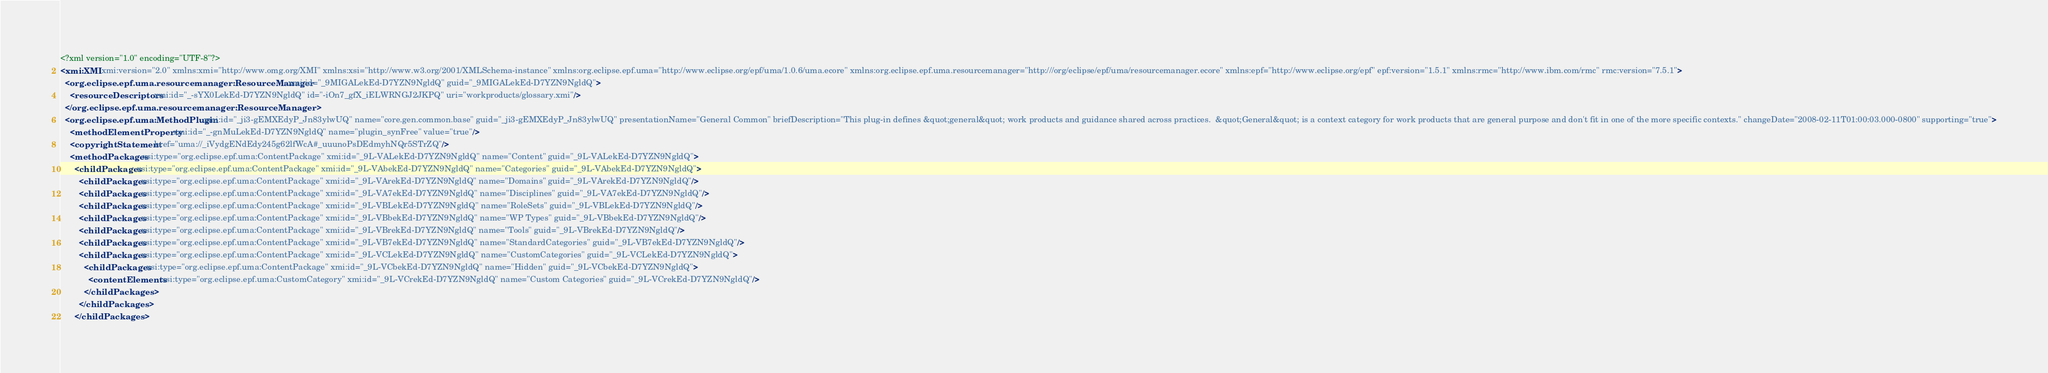<code> <loc_0><loc_0><loc_500><loc_500><_XML_><?xml version="1.0" encoding="UTF-8"?>
<xmi:XMI xmi:version="2.0" xmlns:xmi="http://www.omg.org/XMI" xmlns:xsi="http://www.w3.org/2001/XMLSchema-instance" xmlns:org.eclipse.epf.uma="http://www.eclipse.org/epf/uma/1.0.6/uma.ecore" xmlns:org.eclipse.epf.uma.resourcemanager="http:///org/eclipse/epf/uma/resourcemanager.ecore" xmlns:epf="http://www.eclipse.org/epf" epf:version="1.5.1" xmlns:rmc="http://www.ibm.com/rmc" rmc:version="7.5.1">
  <org.eclipse.epf.uma.resourcemanager:ResourceManager xmi:id="_9MIGALekEd-D7YZN9NgldQ" guid="_9MIGALekEd-D7YZN9NgldQ">
    <resourceDescriptors xmi:id="_-sYX0LekEd-D7YZN9NgldQ" id="-iOn7_gfX_iELWRNGJ2JKPQ" uri="workproducts/glossary.xmi"/>
  </org.eclipse.epf.uma.resourcemanager:ResourceManager>
  <org.eclipse.epf.uma:MethodPlugin xmi:id="_ji3-gEMXEdyP_Jn83ylwUQ" name="core.gen.common.base" guid="_ji3-gEMXEdyP_Jn83ylwUQ" presentationName="General Common" briefDescription="This plug-in defines &quot;general&quot; work products and guidance shared across practices.  &quot;General&quot; is a context category for work products that are general purpose and don't fit in one of the more specific contexts." changeDate="2008-02-11T01:00:03.000-0800" supporting="true">
    <methodElementProperty xmi:id="_-gnMuLekEd-D7YZN9NgldQ" name="plugin_synFree" value="true"/>
    <copyrightStatement href="uma://_iVydgENdEdy245g62lfWcA#_uuunoPsDEdmyhNQr5STrZQ"/>
    <methodPackages xsi:type="org.eclipse.epf.uma:ContentPackage" xmi:id="_9L-VALekEd-D7YZN9NgldQ" name="Content" guid="_9L-VALekEd-D7YZN9NgldQ">
      <childPackages xsi:type="org.eclipse.epf.uma:ContentPackage" xmi:id="_9L-VAbekEd-D7YZN9NgldQ" name="Categories" guid="_9L-VAbekEd-D7YZN9NgldQ">
        <childPackages xsi:type="org.eclipse.epf.uma:ContentPackage" xmi:id="_9L-VArekEd-D7YZN9NgldQ" name="Domains" guid="_9L-VArekEd-D7YZN9NgldQ"/>
        <childPackages xsi:type="org.eclipse.epf.uma:ContentPackage" xmi:id="_9L-VA7ekEd-D7YZN9NgldQ" name="Disciplines" guid="_9L-VA7ekEd-D7YZN9NgldQ"/>
        <childPackages xsi:type="org.eclipse.epf.uma:ContentPackage" xmi:id="_9L-VBLekEd-D7YZN9NgldQ" name="RoleSets" guid="_9L-VBLekEd-D7YZN9NgldQ"/>
        <childPackages xsi:type="org.eclipse.epf.uma:ContentPackage" xmi:id="_9L-VBbekEd-D7YZN9NgldQ" name="WP Types" guid="_9L-VBbekEd-D7YZN9NgldQ"/>
        <childPackages xsi:type="org.eclipse.epf.uma:ContentPackage" xmi:id="_9L-VBrekEd-D7YZN9NgldQ" name="Tools" guid="_9L-VBrekEd-D7YZN9NgldQ"/>
        <childPackages xsi:type="org.eclipse.epf.uma:ContentPackage" xmi:id="_9L-VB7ekEd-D7YZN9NgldQ" name="StandardCategories" guid="_9L-VB7ekEd-D7YZN9NgldQ"/>
        <childPackages xsi:type="org.eclipse.epf.uma:ContentPackage" xmi:id="_9L-VCLekEd-D7YZN9NgldQ" name="CustomCategories" guid="_9L-VCLekEd-D7YZN9NgldQ">
          <childPackages xsi:type="org.eclipse.epf.uma:ContentPackage" xmi:id="_9L-VCbekEd-D7YZN9NgldQ" name="Hidden" guid="_9L-VCbekEd-D7YZN9NgldQ">
            <contentElements xsi:type="org.eclipse.epf.uma:CustomCategory" xmi:id="_9L-VCrekEd-D7YZN9NgldQ" name="Custom Categories" guid="_9L-VCrekEd-D7YZN9NgldQ"/>
          </childPackages>
        </childPackages>
      </childPackages></code> 